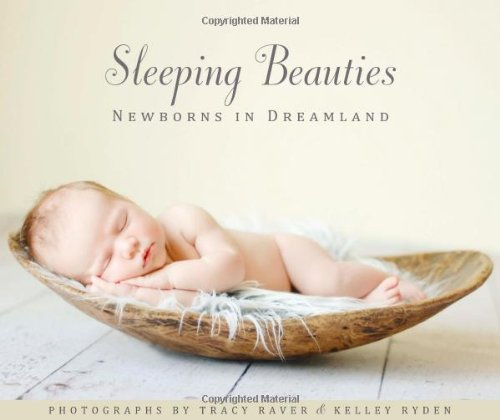What type of book is this? This is an Arts & Photography book, specifically focusing on the artistic representation and photography of newborns captured in peaceful, dreamlike states. 